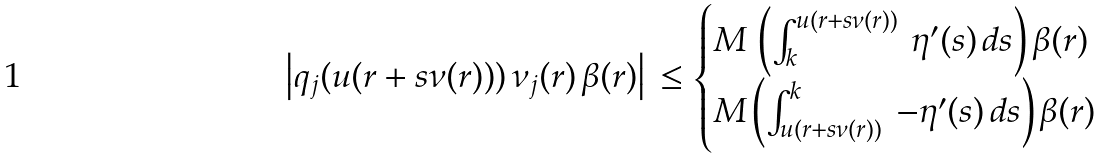<formula> <loc_0><loc_0><loc_500><loc_500>\left | q _ { j } ( u ( r + s \nu ( r ) ) ) \, \nu _ { j } ( r ) \, \beta ( r ) \right | \, \leq \begin{cases} M \, \left ( \int _ { k } ^ { u ( r + s \nu ( r ) ) } \, \eta ^ { \prime } ( s ) \, d s \right ) \beta ( r ) & \\ M \left ( \int _ { u ( r + s \nu ( r ) ) } ^ { k } \, - \eta ^ { \prime } ( s ) \, d s \right ) \beta ( r ) & \end{cases}</formula> 